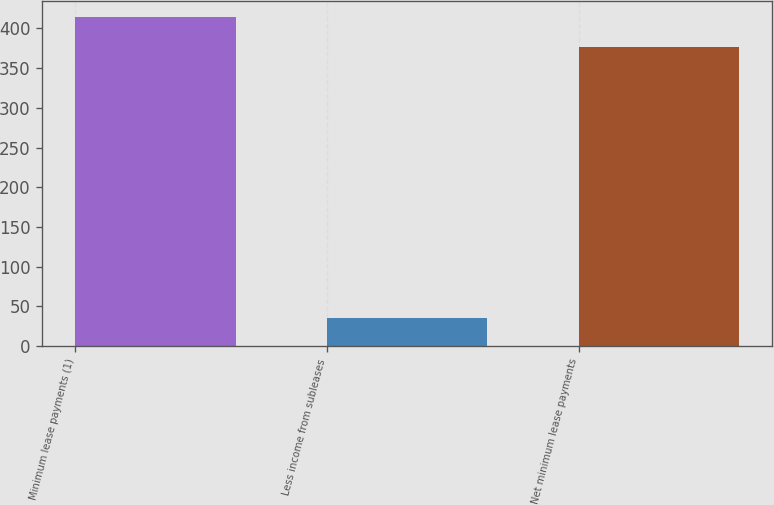Convert chart to OTSL. <chart><loc_0><loc_0><loc_500><loc_500><bar_chart><fcel>Minimum lease payments (1)<fcel>Less income from subleases<fcel>Net minimum lease payments<nl><fcel>413.71<fcel>35.2<fcel>376.1<nl></chart> 